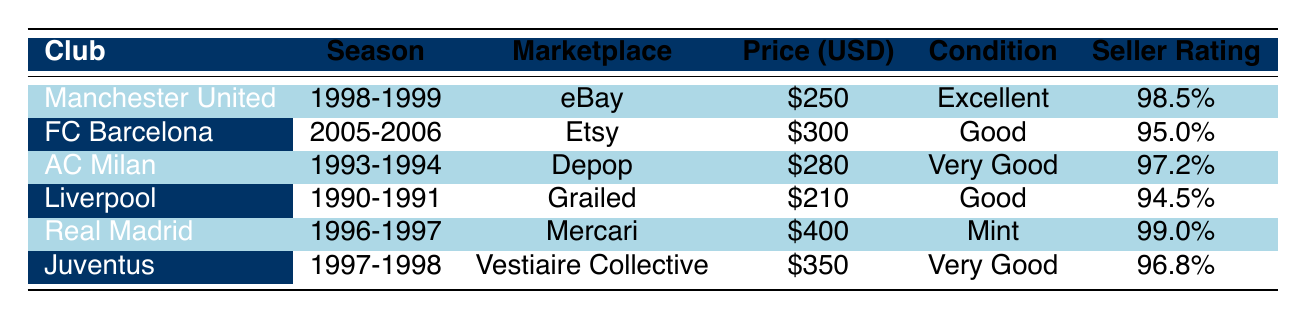What is the price of the Liverpool jersey? The table shows that the price for the Liverpool jersey from the 1990-1991 season is listed as $210.
Answer: 210 Which jersey is the most expensive according to the table? By examining the prices, the Real Madrid jersey from the 1996-1997 season is priced at $400, which is higher than all other jerseys in the table.
Answer: Real Madrid What condition is the Manchester United jersey in? The table states that the condition of the Manchester United jersey from the 1998-1999 season is "Excellent".
Answer: Excellent Is the seller rating for the Juventus jersey above 95%? The seller rating for the Juventus jersey is 96.8%, which is higher than 95%. Therefore, the answer is yes.
Answer: Yes What is the difference in price between the cheapest and the most expensive jerseys? The cheapest jersey is Liverpool at $210 and the most expensive is Real Madrid at $400. The difference is calculated as $400 - $210 = $190.
Answer: 190 Which marketplace offers the FC Barcelona jersey? The table indicates the FC Barcelona jersey from the 2005-2006 season is being sold on Etsy.
Answer: Etsy If I had $300 to spend, which jerseys could I buy? The jerseys priced at or below $300 are Liverpool ($210) and Manchester United ($250). Thus, both jerseys can be purchased for $300 or less.
Answer: Liverpool, Manchester United Does any jersey have a seller rating of 99% or higher? The table shows that the Real Madrid jersey has a seller rating of 99.0%, confirming there is a jersey that meets this criteria.
Answer: Yes What is the average price of the jerseys listed in the table? To find the average, sum the prices: $250 + $300 + $280 + $210 + $400 + $350 = $1790. Then, divide by the number of jerseys (6): $1790 / 6 = $298.33 (approximately).
Answer: 298.33 